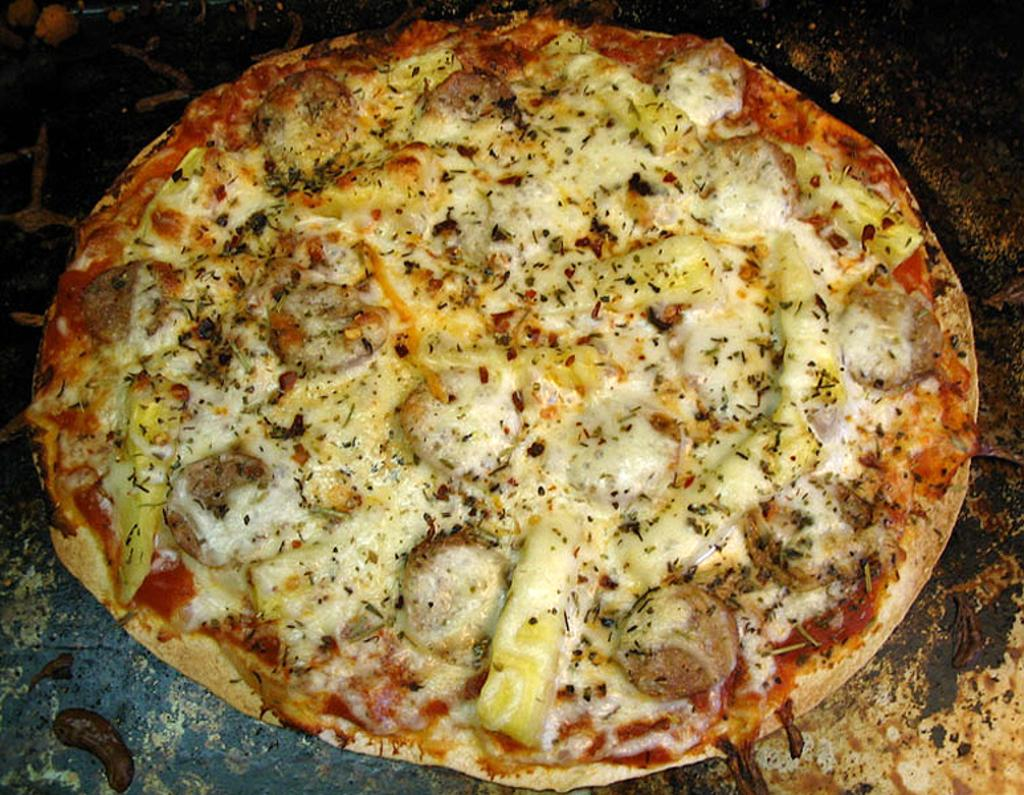What is the main food item in the image? There is a pizza in the image. What else can be seen on the surface in the image? There are other items on a surface in the image. How does the scarecrow compare to the pizza in the image? There is no scarecrow present in the image, so it cannot be compared to the pizza. 